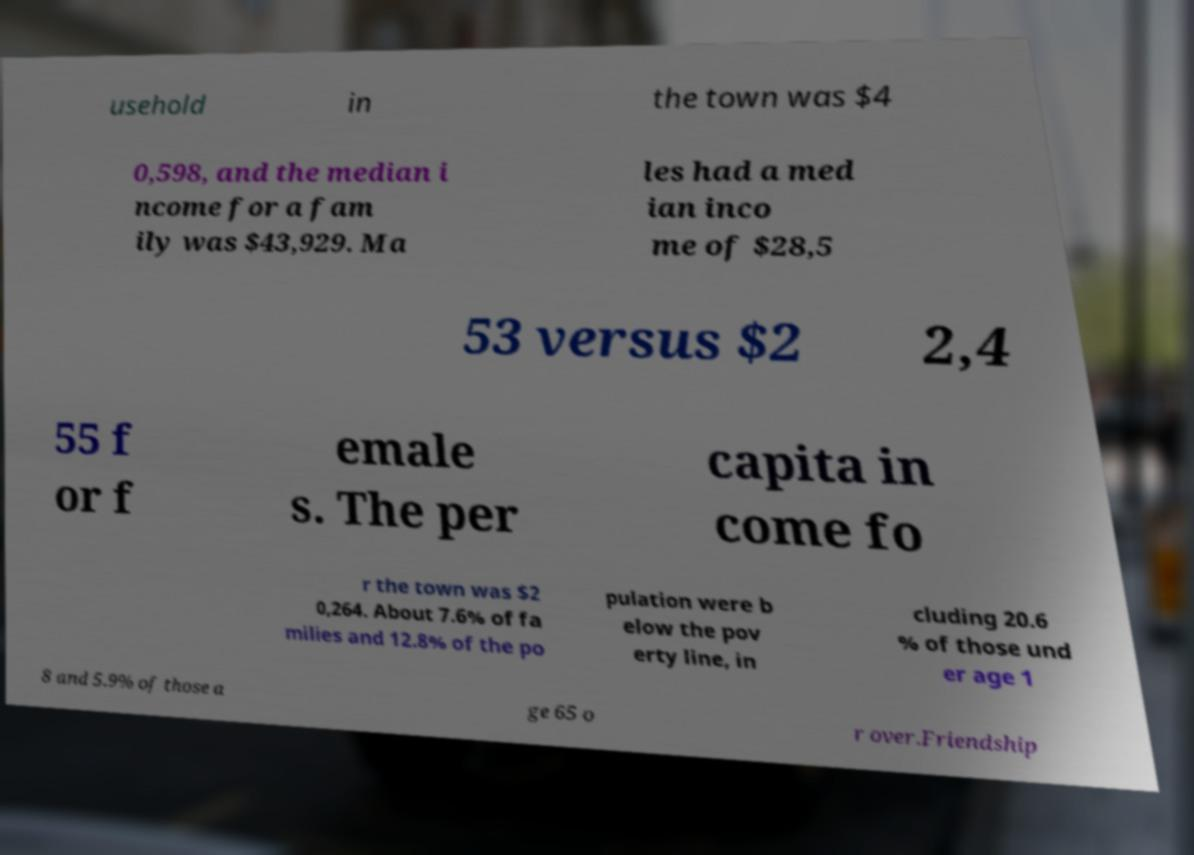I need the written content from this picture converted into text. Can you do that? usehold in the town was $4 0,598, and the median i ncome for a fam ily was $43,929. Ma les had a med ian inco me of $28,5 53 versus $2 2,4 55 f or f emale s. The per capita in come fo r the town was $2 0,264. About 7.6% of fa milies and 12.8% of the po pulation were b elow the pov erty line, in cluding 20.6 % of those und er age 1 8 and 5.9% of those a ge 65 o r over.Friendship 